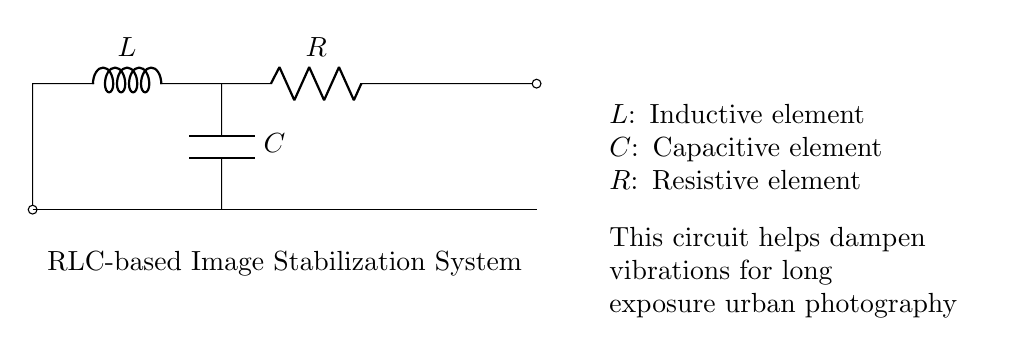What are the components present in the circuit? The circuit contains an inductor (L), a resistor (R), and a capacitor (C). These components are visually represented in the diagram, with labels identifying each one.
Answer: Inductor, resistor, capacitor What is the purpose of the RLC circuit in urban photography? The RLC circuit is designed to dampen vibrations, which is critical during long exposure photography to prevent image blur. The description under the circuit explains its role in stabilizing captured images.
Answer: Dampening vibrations How many components are in the circuit? There are three main components in the circuit: one inductor, one resistor, and one capacitor. Counting these elements directly from the diagram confirms this number.
Answer: Three What type of circuit is this? This is an RLC circuit, which specifically indicates that it contains a resistor, inductor, and capacitor arranged together. The labels on the components corroborate this classification.
Answer: RLC circuit What is the relationship between L, R, and C in this circuit? In an RLC circuit, the inductor (L) stores energy in a magnetic field, the capacitor (C) stores energy in an electric field, and the resistor (R) dissipates energy as heat. This relationship illustrates how these components interact in a circuit for stabilization.
Answer: Energy storage and dissipation What effect does increasing R have on the circuit's function? Increasing R increases the resistance, which leads to greater damping of the circuit's oscillations. This results in improved stabilization as vibrations are reduced more effectively, enhancing image clarity during photography.
Answer: Greater damping What happens to the circuit if C is decreased? Decreasing C reduces the capacitor's ability to store charge, impacting the circuit's responsiveness and damping effect. This could lead to less effective stabilization, resulting in more vibration and potential blur in images.
Answer: Reduced stabilization effectiveness 